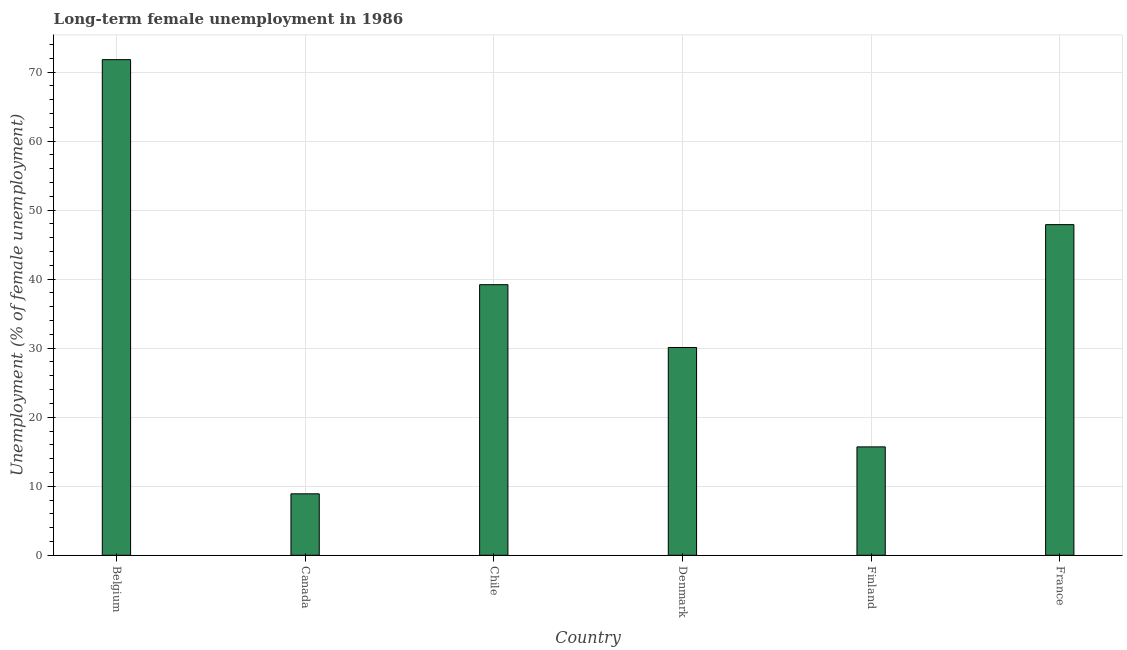Does the graph contain any zero values?
Keep it short and to the point. No. What is the title of the graph?
Make the answer very short. Long-term female unemployment in 1986. What is the label or title of the Y-axis?
Give a very brief answer. Unemployment (% of female unemployment). What is the long-term female unemployment in Chile?
Your answer should be very brief. 39.2. Across all countries, what is the maximum long-term female unemployment?
Offer a very short reply. 71.8. Across all countries, what is the minimum long-term female unemployment?
Provide a succinct answer. 8.9. In which country was the long-term female unemployment maximum?
Offer a very short reply. Belgium. In which country was the long-term female unemployment minimum?
Ensure brevity in your answer.  Canada. What is the sum of the long-term female unemployment?
Your answer should be very brief. 213.6. What is the difference between the long-term female unemployment in Canada and France?
Offer a terse response. -39. What is the average long-term female unemployment per country?
Offer a terse response. 35.6. What is the median long-term female unemployment?
Provide a succinct answer. 34.65. In how many countries, is the long-term female unemployment greater than 4 %?
Provide a short and direct response. 6. What is the ratio of the long-term female unemployment in Canada to that in Finland?
Your response must be concise. 0.57. Is the long-term female unemployment in Belgium less than that in Finland?
Ensure brevity in your answer.  No. What is the difference between the highest and the second highest long-term female unemployment?
Offer a very short reply. 23.9. What is the difference between the highest and the lowest long-term female unemployment?
Offer a terse response. 62.9. How many bars are there?
Provide a short and direct response. 6. What is the Unemployment (% of female unemployment) of Belgium?
Provide a short and direct response. 71.8. What is the Unemployment (% of female unemployment) of Canada?
Ensure brevity in your answer.  8.9. What is the Unemployment (% of female unemployment) in Chile?
Keep it short and to the point. 39.2. What is the Unemployment (% of female unemployment) of Denmark?
Give a very brief answer. 30.1. What is the Unemployment (% of female unemployment) in Finland?
Your response must be concise. 15.7. What is the Unemployment (% of female unemployment) of France?
Offer a very short reply. 47.9. What is the difference between the Unemployment (% of female unemployment) in Belgium and Canada?
Provide a short and direct response. 62.9. What is the difference between the Unemployment (% of female unemployment) in Belgium and Chile?
Make the answer very short. 32.6. What is the difference between the Unemployment (% of female unemployment) in Belgium and Denmark?
Give a very brief answer. 41.7. What is the difference between the Unemployment (% of female unemployment) in Belgium and Finland?
Keep it short and to the point. 56.1. What is the difference between the Unemployment (% of female unemployment) in Belgium and France?
Give a very brief answer. 23.9. What is the difference between the Unemployment (% of female unemployment) in Canada and Chile?
Make the answer very short. -30.3. What is the difference between the Unemployment (% of female unemployment) in Canada and Denmark?
Ensure brevity in your answer.  -21.2. What is the difference between the Unemployment (% of female unemployment) in Canada and France?
Make the answer very short. -39. What is the difference between the Unemployment (% of female unemployment) in Chile and Denmark?
Offer a terse response. 9.1. What is the difference between the Unemployment (% of female unemployment) in Denmark and Finland?
Offer a very short reply. 14.4. What is the difference between the Unemployment (% of female unemployment) in Denmark and France?
Your answer should be very brief. -17.8. What is the difference between the Unemployment (% of female unemployment) in Finland and France?
Provide a succinct answer. -32.2. What is the ratio of the Unemployment (% of female unemployment) in Belgium to that in Canada?
Provide a short and direct response. 8.07. What is the ratio of the Unemployment (% of female unemployment) in Belgium to that in Chile?
Keep it short and to the point. 1.83. What is the ratio of the Unemployment (% of female unemployment) in Belgium to that in Denmark?
Ensure brevity in your answer.  2.38. What is the ratio of the Unemployment (% of female unemployment) in Belgium to that in Finland?
Make the answer very short. 4.57. What is the ratio of the Unemployment (% of female unemployment) in Belgium to that in France?
Offer a very short reply. 1.5. What is the ratio of the Unemployment (% of female unemployment) in Canada to that in Chile?
Your response must be concise. 0.23. What is the ratio of the Unemployment (% of female unemployment) in Canada to that in Denmark?
Offer a terse response. 0.3. What is the ratio of the Unemployment (% of female unemployment) in Canada to that in Finland?
Provide a succinct answer. 0.57. What is the ratio of the Unemployment (% of female unemployment) in Canada to that in France?
Offer a terse response. 0.19. What is the ratio of the Unemployment (% of female unemployment) in Chile to that in Denmark?
Keep it short and to the point. 1.3. What is the ratio of the Unemployment (% of female unemployment) in Chile to that in Finland?
Your answer should be compact. 2.5. What is the ratio of the Unemployment (% of female unemployment) in Chile to that in France?
Make the answer very short. 0.82. What is the ratio of the Unemployment (% of female unemployment) in Denmark to that in Finland?
Ensure brevity in your answer.  1.92. What is the ratio of the Unemployment (% of female unemployment) in Denmark to that in France?
Your answer should be very brief. 0.63. What is the ratio of the Unemployment (% of female unemployment) in Finland to that in France?
Provide a short and direct response. 0.33. 